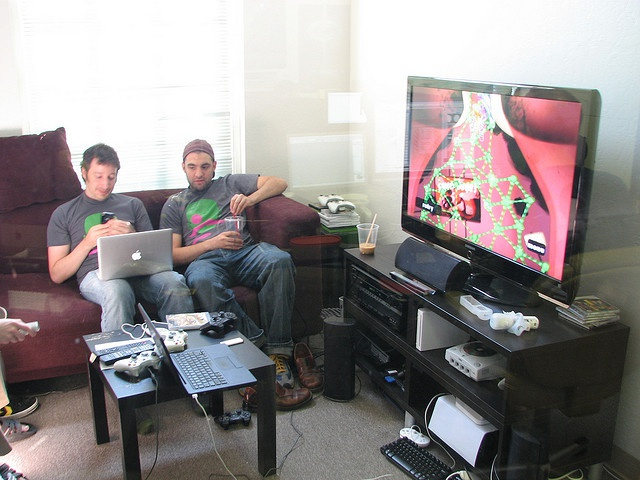Describe the objects in this image and their specific colors. I can see tv in white, lightpink, black, and gray tones, people in white, black, gray, tan, and blue tones, people in white, gray, lightpink, darkgray, and lightgray tones, couch in white, maroon, black, brown, and gray tones, and couch in white, purple, black, and brown tones in this image. 